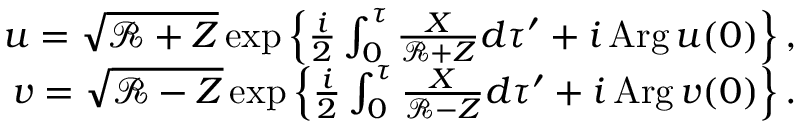Convert formula to latex. <formula><loc_0><loc_0><loc_500><loc_500>\begin{array} { r } { u = \sqrt { \mathcal { R } + Z } \exp \left \{ \frac { i } { 2 } \int _ { 0 } ^ { \tau } \frac { X } { \mathcal { R } + Z } d \tau ^ { \prime } + i \, A r g \, u ( 0 ) \right \} , } \\ { v = \sqrt { \mathcal { R } - Z } \exp \left \{ \frac { i } { 2 } \int _ { 0 } ^ { \tau } \frac { X } { \mathcal { R } - Z } d \tau ^ { \prime } + i \, A r g \, v ( 0 ) \right \} . } \end{array}</formula> 